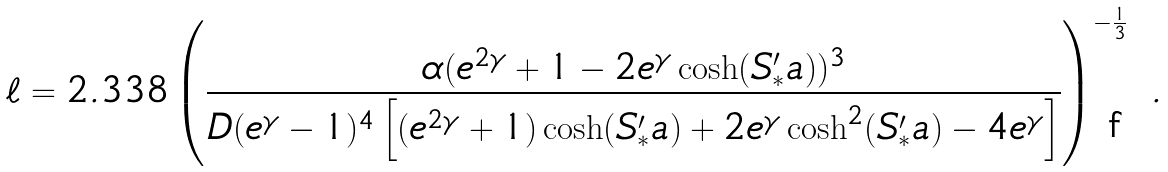<formula> <loc_0><loc_0><loc_500><loc_500>\ell = 2 . 3 3 8 \left ( \frac { \alpha ( e ^ { 2 \gamma } + 1 - 2 e ^ { \gamma } \cosh ( S ^ { \prime } _ { * } a ) ) ^ { 3 } } { D ( e ^ { \gamma } - 1 ) ^ { 4 } \left [ ( e ^ { 2 \gamma } + 1 ) \cosh ( S ^ { \prime } _ { * } a ) + 2 e ^ { \gamma } \cosh ^ { 2 } ( S ^ { \prime } _ { * } a ) - 4 e ^ { \gamma } \right ] } \right ) ^ { - \frac { 1 } { 3 } } \ .</formula> 